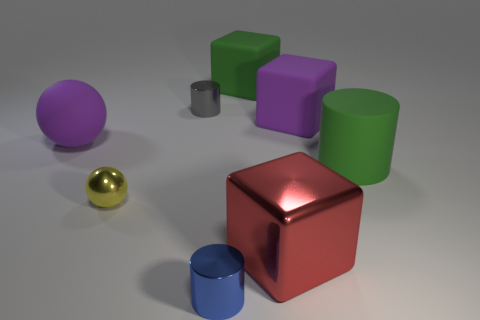Is the number of red blocks that are behind the big red metal block the same as the number of green rubber things? no 